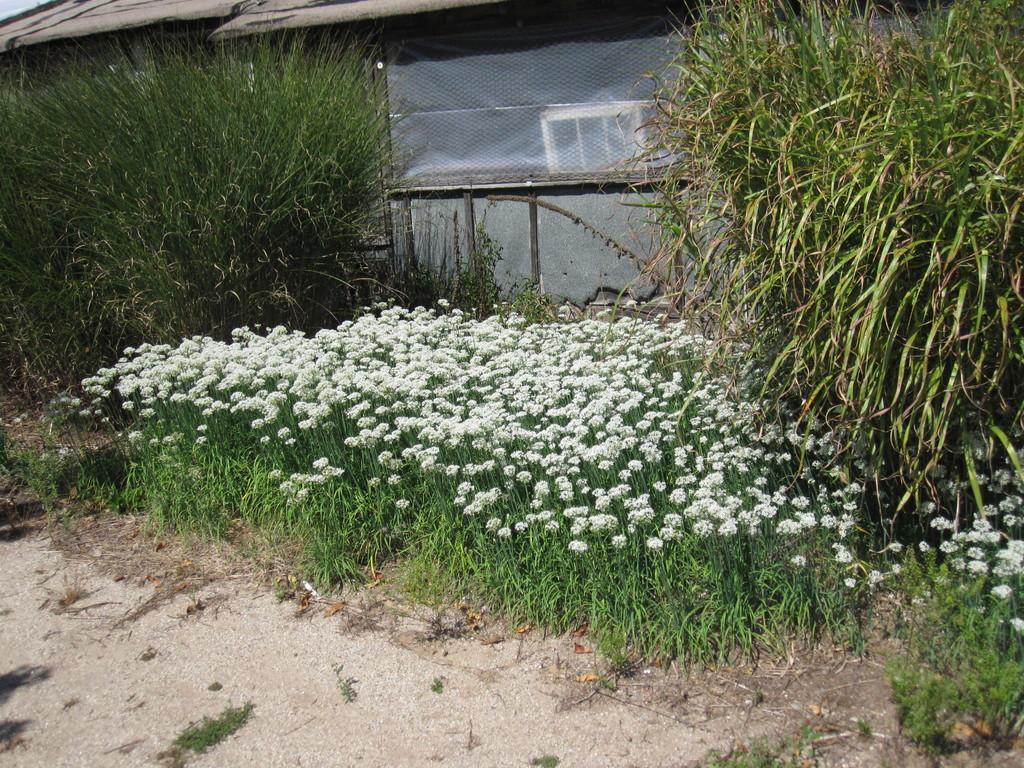How would you summarize this image in a sentence or two? In this image we can see a house. There are many plants in the image. There are many flowers to the plants in the image. 